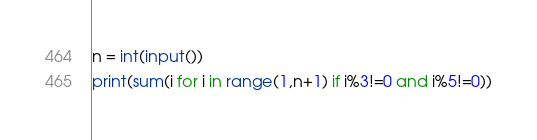Convert code to text. <code><loc_0><loc_0><loc_500><loc_500><_Python_>n = int(input())
print(sum(i for i in range(1,n+1) if i%3!=0 and i%5!=0))</code> 